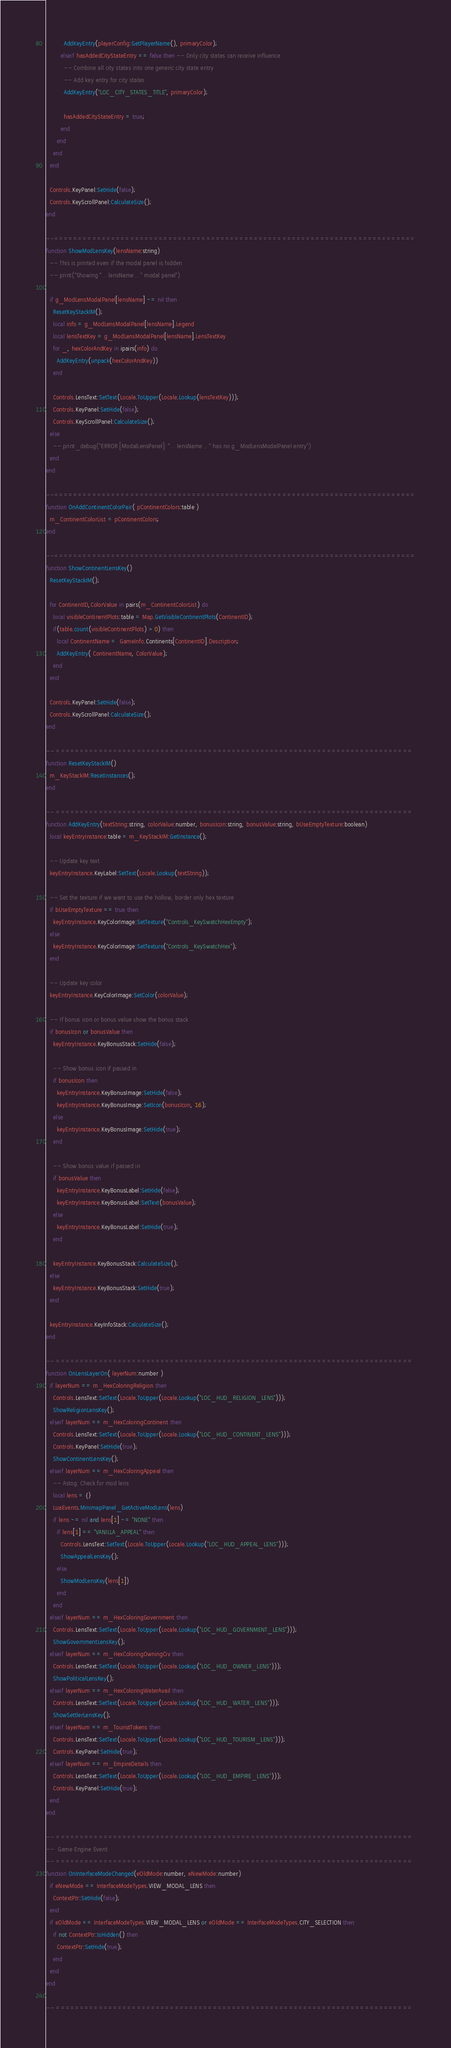Convert code to text. <code><loc_0><loc_0><loc_500><loc_500><_Lua_>          AddKeyEntry(playerConfig:GetPlayerName(), primaryColor);
        elseif hasAddedCityStateEntry == false then -- Only city states can receive influence
          -- Combine all city states into one generic city state entry
          -- Add key entry for city states
          AddKeyEntry("LOC_CITY_STATES_TITLE", primaryColor);

          hasAddedCityStateEntry = true;
        end
      end
    end
  end

  Controls.KeyPanel:SetHide(false);
  Controls.KeyScrollPanel:CalculateSize();
end

--============================================================================
function ShowModLensKey(lensName:string)
  -- This is printed even if the modal panel is hidden
  -- print("Showing " .. lensName .. " modal panel")

  if g_ModLensModalPanel[lensName] ~= nil then
    ResetKeyStackIM();
    local info = g_ModLensModalPanel[lensName].Legend
    local lensTextKey = g_ModLensModalPanel[lensName].LensTextKey
    for _, hexColorAndKey in ipairs(info) do
      AddKeyEntry(unpack(hexColorAndKey))
    end

    Controls.LensText:SetText(Locale.ToUpper(Locale.Lookup(lensTextKey)));
    Controls.KeyPanel:SetHide(false);
    Controls.KeyScrollPanel:CalculateSize();
  else
    -- print_debug("ERROR [ModalLensPanel]: " .. lensName .. " has no g_ModLensModalPanel entry")
  end
end

--============================================================================
function OnAddContinentColorPair( pContinentColors:table )
  m_ContinentColorList = pContinentColors;
end

--============================================================================
function ShowContinentLensKey()
  ResetKeyStackIM();

  for ContinentID,ColorValue in pairs(m_ContinentColorList) do
    local visibleContinentPlots:table = Map.GetVisibleContinentPlots(ContinentID);
    if(table.count(visibleContinentPlots) > 0) then
      local ContinentName =  GameInfo.Continents[ContinentID].Description;
      AddKeyEntry( ContinentName, ColorValue);
    end
  end

  Controls.KeyPanel:SetHide(false);
  Controls.KeyScrollPanel:CalculateSize();
end

-- ===========================================================================
function ResetKeyStackIM()
  m_KeyStackIM:ResetInstances();
end

-- ===========================================================================
function AddKeyEntry(textString:string, colorValue:number, bonusIcon:string, bonusValue:string, bUseEmptyTexture:boolean)
  local keyEntryInstance:table = m_KeyStackIM:GetInstance();

  -- Update key text
  keyEntryInstance.KeyLabel:SetText(Locale.Lookup(textString));

  -- Set the texture if we want to use the hollow, border only hex texture
  if bUseEmptyTexture == true then
    keyEntryInstance.KeyColorImage:SetTexture("Controls_KeySwatchHexEmpty");
  else
    keyEntryInstance.KeyColorImage:SetTexture("Controls_KeySwatchHex");
  end

  -- Update key color
  keyEntryInstance.KeyColorImage:SetColor(colorValue);

  -- If bonus icon or bonus value show the bonus stack
  if bonusIcon or bonusValue then
    keyEntryInstance.KeyBonusStack:SetHide(false);

    -- Show bonus icon if passed in
    if bonusIcon then
      keyEntryInstance.KeyBonusImage:SetHide(false);
      keyEntryInstance.KeyBonusImage:SetIcon(bonusIcon, 16);
    else
      keyEntryInstance.KeyBonusImage:SetHide(true);
    end

    -- Show bonus value if passed in
    if bonusValue then
      keyEntryInstance.KeyBonusLabel:SetHide(false);
      keyEntryInstance.KeyBonusLabel:SetText(bonusValue);
    else
      keyEntryInstance.KeyBonusLabel:SetHide(true);
    end

    keyEntryInstance.KeyBonusStack:CalculateSize();
  else
    keyEntryInstance.KeyBonusStack:SetHide(true);
  end

  keyEntryInstance.KeyInfoStack:CalculateSize();
end

-- ===========================================================================
function OnLensLayerOn( layerNum:number )
  if layerNum == m_HexColoringReligion then
    Controls.LensText:SetText(Locale.ToUpper(Locale.Lookup("LOC_HUD_RELIGION_LENS")));
    ShowReligionLensKey();
  elseif layerNum == m_HexColoringContinent then
    Controls.LensText:SetText(Locale.ToUpper(Locale.Lookup("LOC_HUD_CONTINENT_LENS")));
    Controls.KeyPanel:SetHide(true);
    ShowContinentLensKey();
  elseif layerNum == m_HexColoringAppeal then
    -- Astog: Check for mod lens
    local lens = {}
    LuaEvents.MinimapPanel_GetActiveModLens(lens)
    if lens ~= nil and lens[1] ~= "NONE" then
      if lens[1] == "VANILLA_APPEAL" then
        Controls.LensText:SetText(Locale.ToUpper(Locale.Lookup("LOC_HUD_APPEAL_LENS")));
        ShowAppealLensKey();
      else
        ShowModLensKey(lens[1])
      end
    end
  elseif layerNum == m_HexColoringGovernment then
    Controls.LensText:SetText(Locale.ToUpper(Locale.Lookup("LOC_HUD_GOVERNMENT_LENS")));
    ShowGovernmentLensKey();
  elseif layerNum == m_HexColoringOwningCiv then
    Controls.LensText:SetText(Locale.ToUpper(Locale.Lookup("LOC_HUD_OWNER_LENS")));
    ShowPoliticalLensKey();
  elseif layerNum == m_HexColoringWaterAvail then
    Controls.LensText:SetText(Locale.ToUpper(Locale.Lookup("LOC_HUD_WATER_LENS")));
    ShowSettlerLensKey();
  elseif layerNum == m_TouristTokens then
    Controls.LensText:SetText(Locale.ToUpper(Locale.Lookup("LOC_HUD_TOURISM_LENS")));
    Controls.KeyPanel:SetHide(true);
  elseif layerNum == m_EmpireDetails then
    Controls.LensText:SetText(Locale.ToUpper(Locale.Lookup("LOC_HUD_EMPIRE_LENS")));
    Controls.KeyPanel:SetHide(true);
  end
end

-- ===========================================================================
--  Game Engine Event
-- ===========================================================================
function OnInterfaceModeChanged(eOldMode:number, eNewMode:number)
  if eNewMode == InterfaceModeTypes.VIEW_MODAL_LENS then
    ContextPtr:SetHide(false);
  end
  if eOldMode == InterfaceModeTypes.VIEW_MODAL_LENS or eOldMode == InterfaceModeTypes.CITY_SELECTION then
    if not ContextPtr:IsHidden() then
      ContextPtr:SetHide(true);
    end
  end
end

-- ===========================================================================</code> 